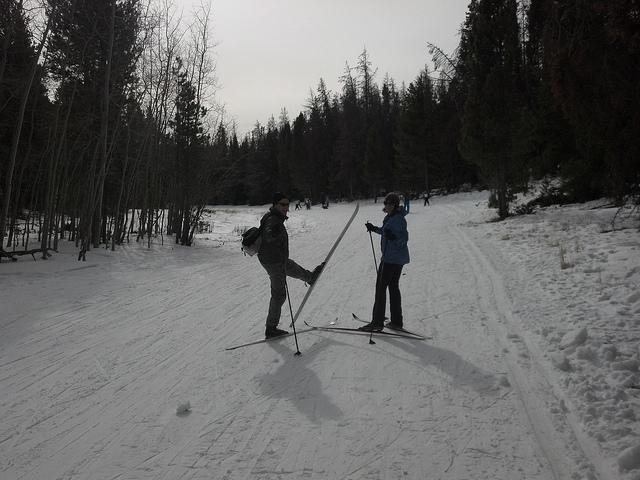How many people are in the picture?
Give a very brief answer. 2. 